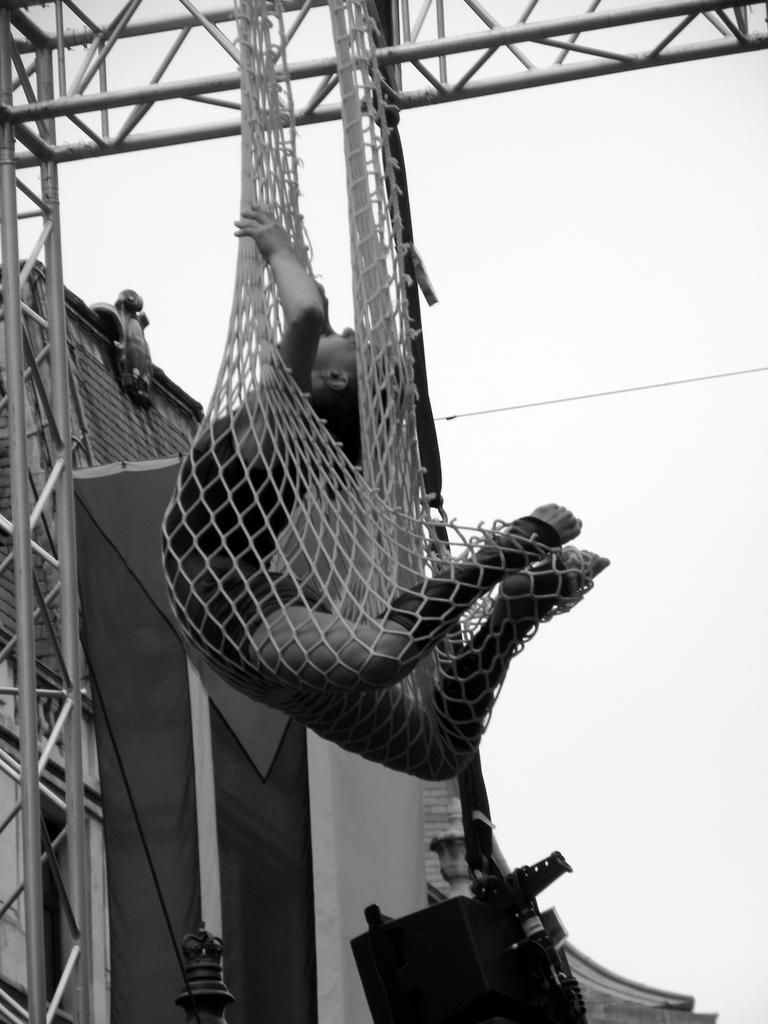Can you describe this image briefly? Here in this picture we can see a person trapped in a net, which is hanging over the iron frame present over there and in front of it we can see a house also present over there. 